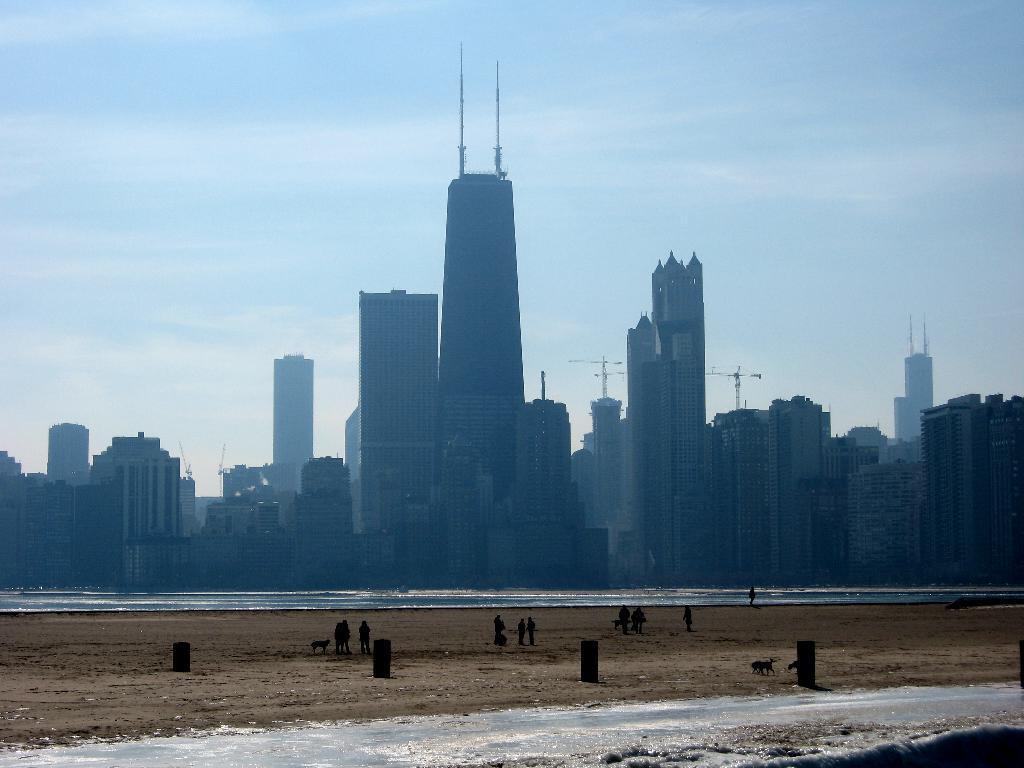Can you describe this image briefly? In this image, we can see people and some animals. In the background, there are buildings. At the bottom, there is water and sand. 